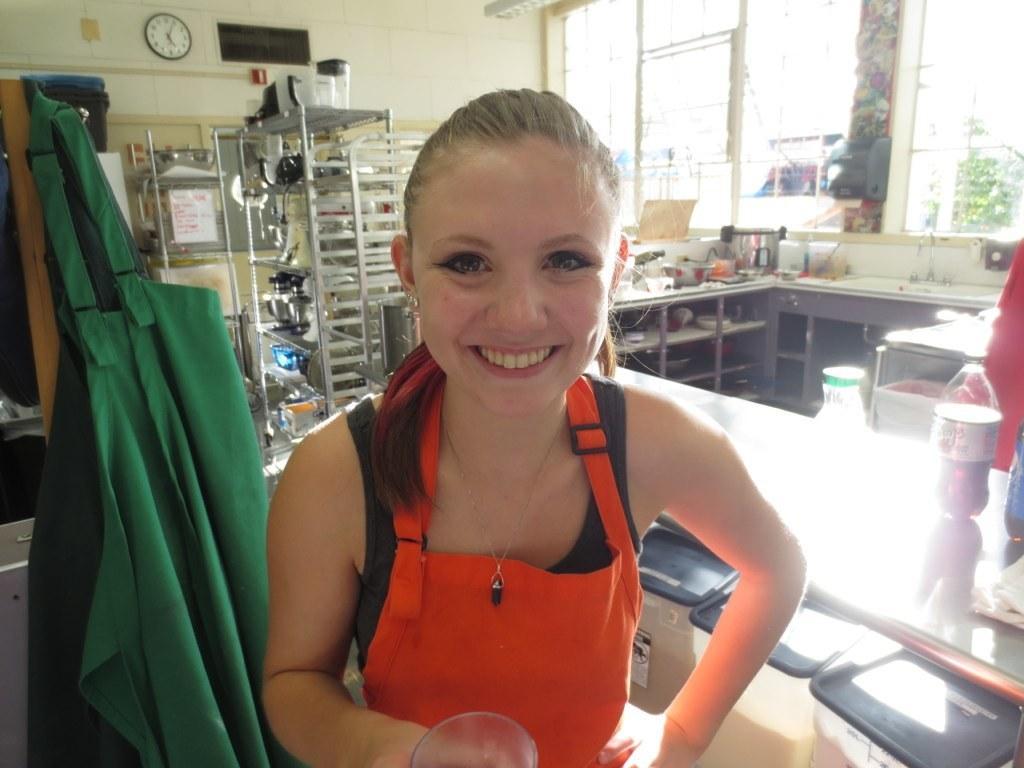Describe this image in one or two sentences. In this image, we can see a woman is watching and smiling. She is holding some object. Background we can see iron racks, few things, objects, bottles, containers, tables, apron, wall. Top of the image, we can see the clock. Here we can see glass windows. 